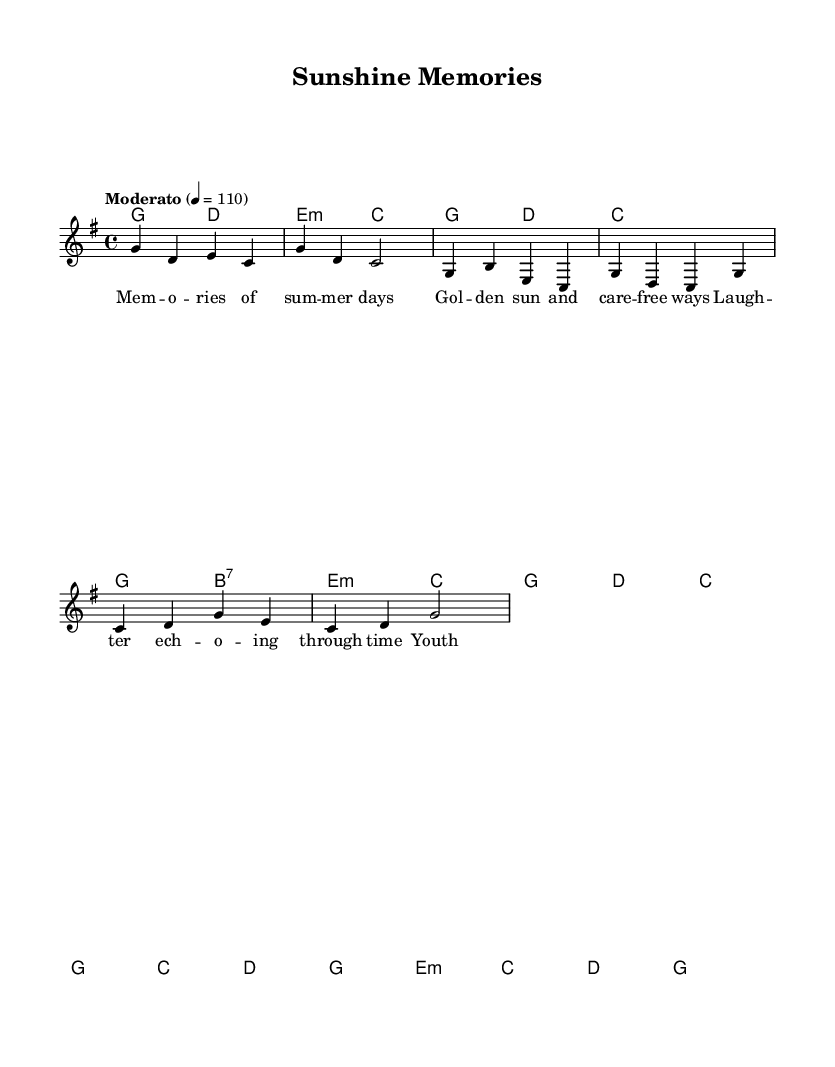What is the key signature of this music? The key signature indicates that the piece is in G major, which has one sharp (F#). This can be seen at the beginning of the staff where the key signature is displayed.
Answer: G major What is the time signature of the piece? The time signature is found at the beginning of the sheet music and is displayed as 4/4. This means there are four beats in each measure, and a quarter note gets one beat.
Answer: 4/4 What tempo marking is indicated in the music? The tempo marking is listed at the beginning above the staff, stating "Moderato" with a metronome marking of quarter note equals 110 beats per minute. This suggests a moderate pace for the performance.
Answer: Moderato, 110 How many measures are in the verse? By counting the measures linearly for the verse section, which is indicated in the score, we find there are four measures in the verse part.
Answer: 4 What type of chord is used in the first measure of the intro? The chord in the first measure is G major, which can be confirmed by the chord symbols above the staff in the harmonies section.
Answer: G What is the final chord of the chorus? The final chord of the chorus, as indicated in the harmonies, is G major, which appears in the last measure of the chorus section indicated by the chord symbol.
Answer: G 